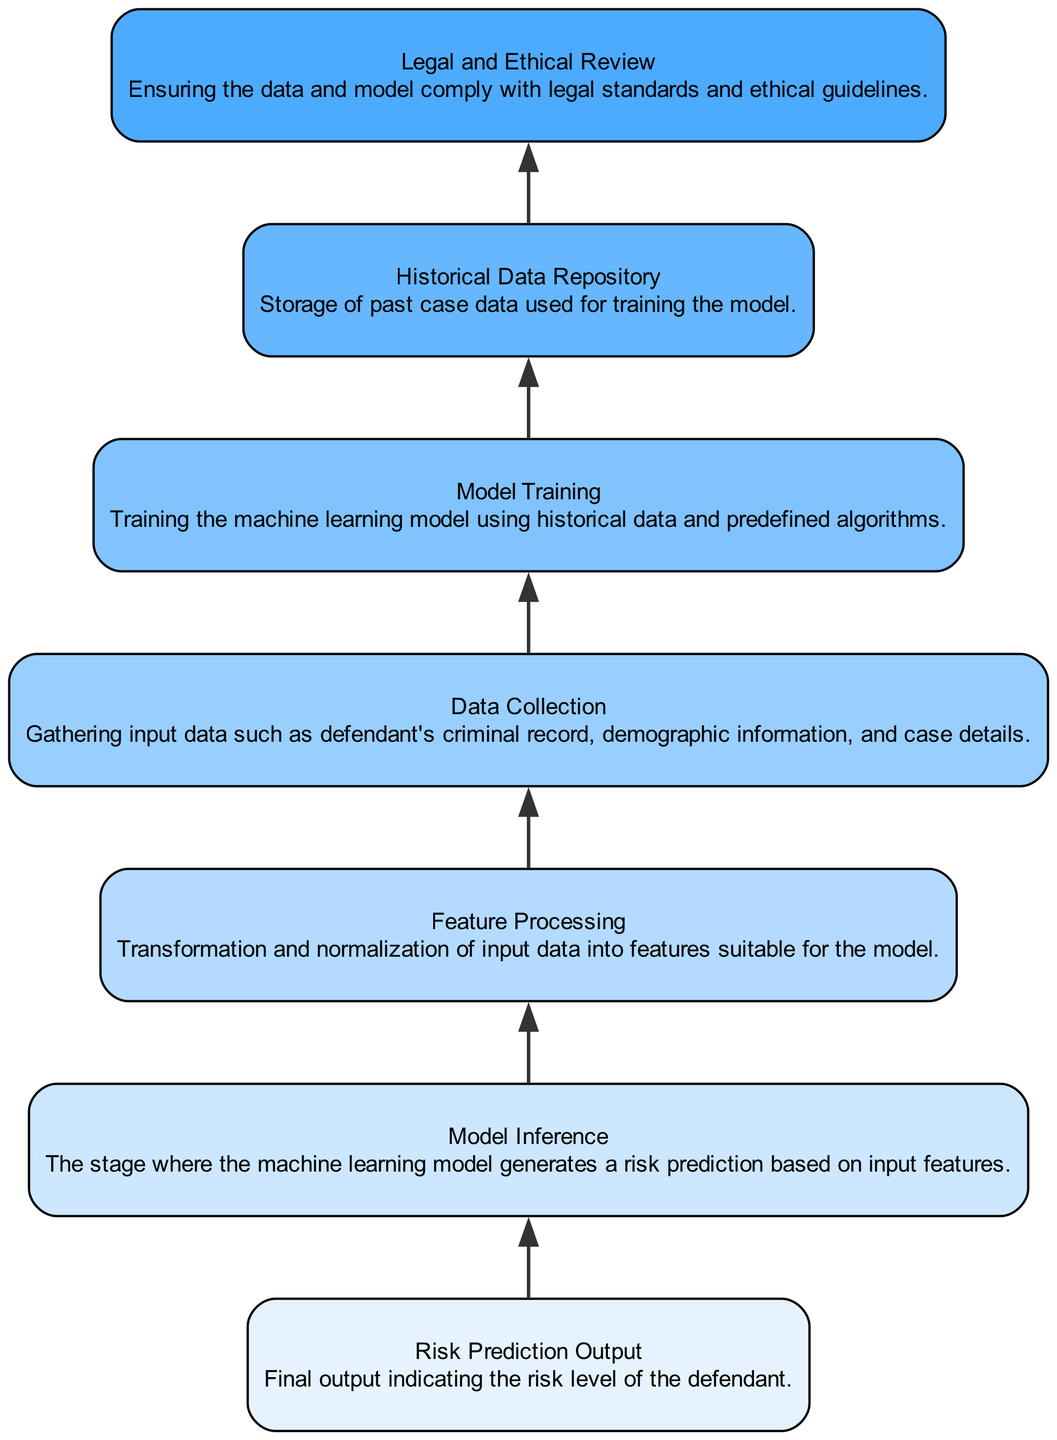What is the highest level output of this diagram? The highest level output in the flowchart is "Risk Prediction Output," which indicates the risk level of the defendant.
Answer: Risk Prediction Output What node comes directly after "Model Training"? According to the flow of the diagram, "Model Training" is followed directly by "Historical Data Repository," which stores past case data used for training the model.
Answer: Historical Data Repository How many nodes are present in this diagram? The diagram contains a total of seven nodes, representing different stages of the risk assessment tool implementation.
Answer: Seven Which stage involves gathering input data? The node "Data Collection" represents the stage where input data is gathered, including details like the defendant's criminal record and demographic information.
Answer: Data Collection What ensures compliance with legal standards? The "Legal and Ethical Review" node is dedicated to ensuring that the data and model comply with legal standards and ethical guidelines.
Answer: Legal and Ethical Review What is the direction of flow in this diagram? The flow in this diagram moves from the bottom to the top, as indicated by the arrangement of the nodes where each stage leads to the subsequent stage above it.
Answer: Bottom to top Which node is responsible for transforming data into features? The "Feature Processing" node is responsible for transforming and normalizing input data into features suitable for the machine learning model.
Answer: Feature Processing How many edges are present connecting the nodes? There are six edges in the diagram, connecting each of the seven nodes sequentially from the bottommost node to the topmost one.
Answer: Six 